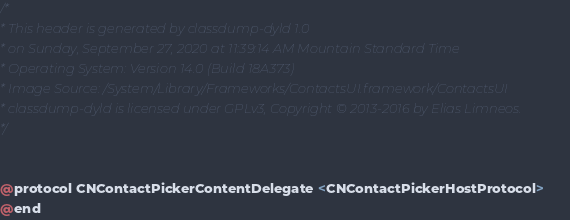Convert code to text. <code><loc_0><loc_0><loc_500><loc_500><_C_>/*
* This header is generated by classdump-dyld 1.0
* on Sunday, September 27, 2020 at 11:39:14 AM Mountain Standard Time
* Operating System: Version 14.0 (Build 18A373)
* Image Source: /System/Library/Frameworks/ContactsUI.framework/ContactsUI
* classdump-dyld is licensed under GPLv3, Copyright © 2013-2016 by Elias Limneos.
*/


@protocol CNContactPickerContentDelegate <CNContactPickerHostProtocol>
@end

</code> 